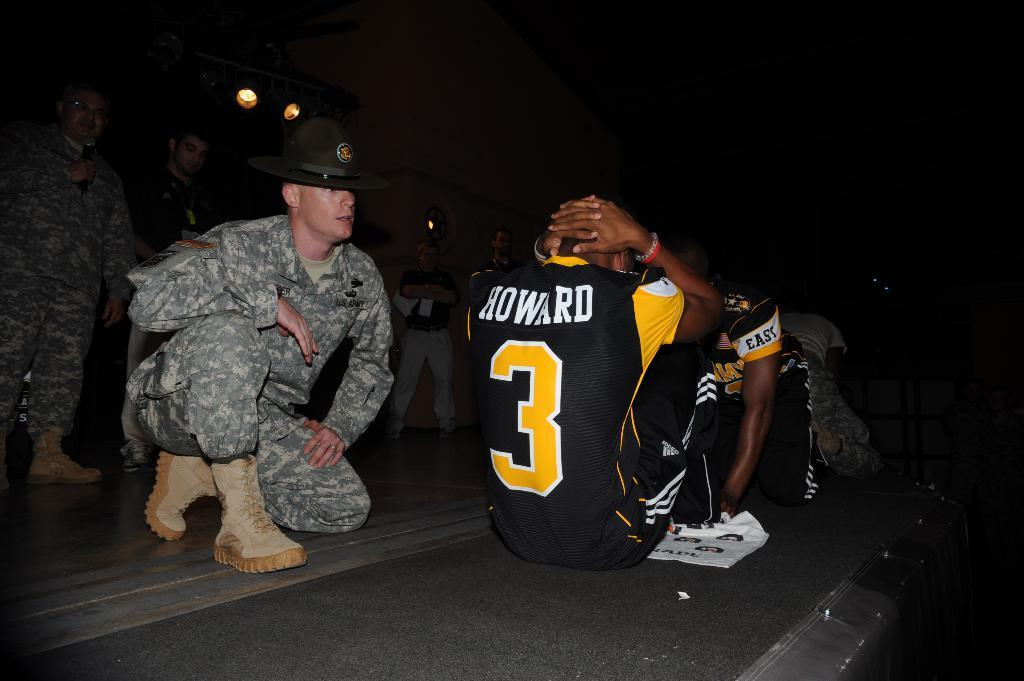Provide a one-sentence caption for the provided image. A man in a Howard number 3 jersey is doing sit ups in front of an Army Drill Sergeant. 